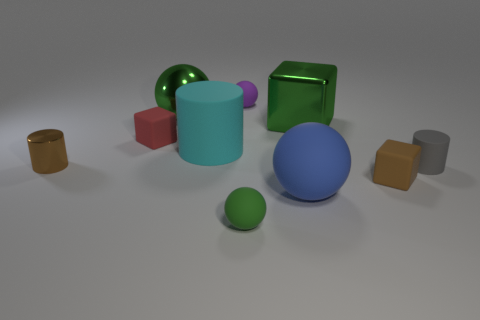Subtract all balls. How many objects are left? 6 Add 9 big green metal blocks. How many big green metal blocks are left? 10 Add 9 big blue matte objects. How many big blue matte objects exist? 10 Subtract 0 cyan spheres. How many objects are left? 10 Subtract all cyan cylinders. Subtract all metal cylinders. How many objects are left? 8 